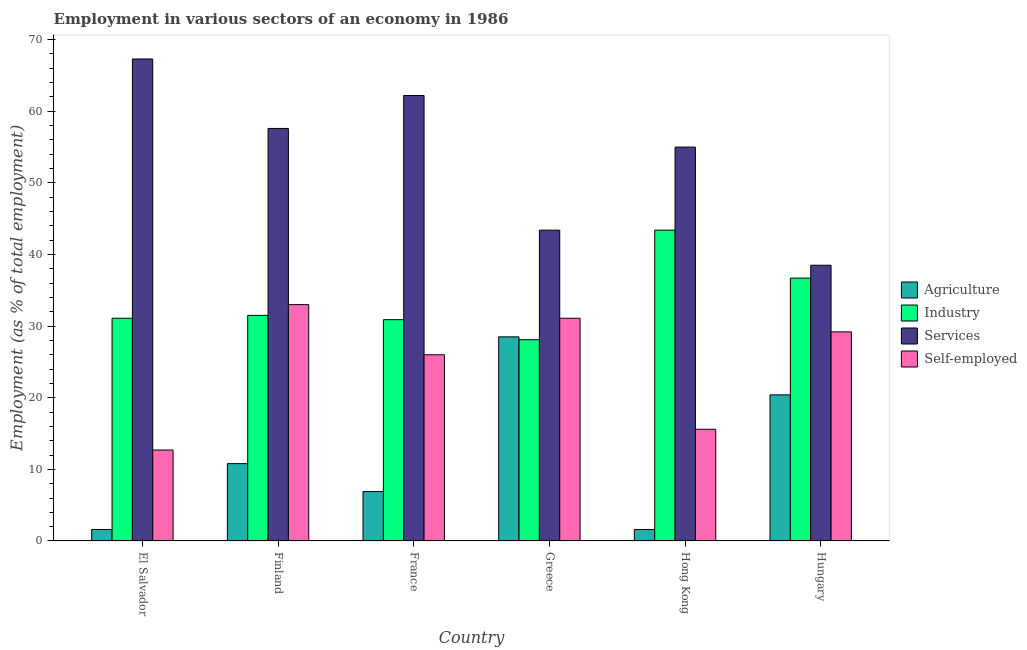How many different coloured bars are there?
Provide a succinct answer. 4. Are the number of bars per tick equal to the number of legend labels?
Keep it short and to the point. Yes. Are the number of bars on each tick of the X-axis equal?
Ensure brevity in your answer.  Yes. What is the label of the 5th group of bars from the left?
Provide a succinct answer. Hong Kong. In how many cases, is the number of bars for a given country not equal to the number of legend labels?
Ensure brevity in your answer.  0. What is the percentage of self employed workers in Hungary?
Your answer should be very brief. 29.2. Across all countries, what is the minimum percentage of workers in industry?
Make the answer very short. 28.1. In which country was the percentage of workers in industry minimum?
Give a very brief answer. Greece. What is the total percentage of self employed workers in the graph?
Offer a very short reply. 147.6. What is the difference between the percentage of self employed workers in El Salvador and that in Finland?
Your answer should be compact. -20.3. What is the difference between the percentage of workers in services in El Salvador and the percentage of workers in agriculture in Hong Kong?
Your answer should be compact. 65.7. What is the average percentage of workers in industry per country?
Provide a short and direct response. 33.62. What is the difference between the percentage of self employed workers and percentage of workers in agriculture in France?
Offer a terse response. 19.1. In how many countries, is the percentage of self employed workers greater than 10 %?
Offer a very short reply. 6. What is the ratio of the percentage of self employed workers in Finland to that in Hong Kong?
Give a very brief answer. 2.12. Is the percentage of workers in services in El Salvador less than that in France?
Your answer should be compact. No. Is the difference between the percentage of workers in agriculture in Hong Kong and Hungary greater than the difference between the percentage of self employed workers in Hong Kong and Hungary?
Provide a succinct answer. No. What is the difference between the highest and the second highest percentage of workers in services?
Offer a terse response. 5.1. What is the difference between the highest and the lowest percentage of workers in services?
Your answer should be very brief. 28.8. Is the sum of the percentage of self employed workers in France and Greece greater than the maximum percentage of workers in industry across all countries?
Offer a terse response. Yes. Is it the case that in every country, the sum of the percentage of workers in services and percentage of workers in industry is greater than the sum of percentage of workers in agriculture and percentage of self employed workers?
Provide a short and direct response. Yes. What does the 3rd bar from the left in El Salvador represents?
Make the answer very short. Services. What does the 3rd bar from the right in Greece represents?
Give a very brief answer. Industry. Is it the case that in every country, the sum of the percentage of workers in agriculture and percentage of workers in industry is greater than the percentage of workers in services?
Ensure brevity in your answer.  No. How many countries are there in the graph?
Your answer should be compact. 6. What is the difference between two consecutive major ticks on the Y-axis?
Offer a terse response. 10. Does the graph contain any zero values?
Ensure brevity in your answer.  No. How many legend labels are there?
Your answer should be compact. 4. What is the title of the graph?
Provide a succinct answer. Employment in various sectors of an economy in 1986. Does "Taxes on income" appear as one of the legend labels in the graph?
Provide a short and direct response. No. What is the label or title of the X-axis?
Provide a short and direct response. Country. What is the label or title of the Y-axis?
Your answer should be compact. Employment (as % of total employment). What is the Employment (as % of total employment) in Agriculture in El Salvador?
Ensure brevity in your answer.  1.6. What is the Employment (as % of total employment) in Industry in El Salvador?
Ensure brevity in your answer.  31.1. What is the Employment (as % of total employment) in Services in El Salvador?
Offer a terse response. 67.3. What is the Employment (as % of total employment) in Self-employed in El Salvador?
Make the answer very short. 12.7. What is the Employment (as % of total employment) in Agriculture in Finland?
Provide a short and direct response. 10.8. What is the Employment (as % of total employment) of Industry in Finland?
Ensure brevity in your answer.  31.5. What is the Employment (as % of total employment) of Services in Finland?
Offer a terse response. 57.6. What is the Employment (as % of total employment) of Agriculture in France?
Offer a terse response. 6.9. What is the Employment (as % of total employment) of Industry in France?
Make the answer very short. 30.9. What is the Employment (as % of total employment) of Services in France?
Offer a very short reply. 62.2. What is the Employment (as % of total employment) in Self-employed in France?
Give a very brief answer. 26. What is the Employment (as % of total employment) in Industry in Greece?
Your answer should be compact. 28.1. What is the Employment (as % of total employment) in Services in Greece?
Ensure brevity in your answer.  43.4. What is the Employment (as % of total employment) of Self-employed in Greece?
Give a very brief answer. 31.1. What is the Employment (as % of total employment) of Agriculture in Hong Kong?
Keep it short and to the point. 1.6. What is the Employment (as % of total employment) in Industry in Hong Kong?
Offer a terse response. 43.4. What is the Employment (as % of total employment) of Self-employed in Hong Kong?
Make the answer very short. 15.6. What is the Employment (as % of total employment) in Agriculture in Hungary?
Ensure brevity in your answer.  20.4. What is the Employment (as % of total employment) of Industry in Hungary?
Offer a terse response. 36.7. What is the Employment (as % of total employment) in Services in Hungary?
Keep it short and to the point. 38.5. What is the Employment (as % of total employment) in Self-employed in Hungary?
Offer a terse response. 29.2. Across all countries, what is the maximum Employment (as % of total employment) of Agriculture?
Provide a succinct answer. 28.5. Across all countries, what is the maximum Employment (as % of total employment) of Industry?
Provide a short and direct response. 43.4. Across all countries, what is the maximum Employment (as % of total employment) in Services?
Your response must be concise. 67.3. Across all countries, what is the minimum Employment (as % of total employment) of Agriculture?
Offer a very short reply. 1.6. Across all countries, what is the minimum Employment (as % of total employment) in Industry?
Keep it short and to the point. 28.1. Across all countries, what is the minimum Employment (as % of total employment) in Services?
Keep it short and to the point. 38.5. Across all countries, what is the minimum Employment (as % of total employment) of Self-employed?
Make the answer very short. 12.7. What is the total Employment (as % of total employment) in Agriculture in the graph?
Offer a very short reply. 69.8. What is the total Employment (as % of total employment) of Industry in the graph?
Make the answer very short. 201.7. What is the total Employment (as % of total employment) of Services in the graph?
Offer a very short reply. 324. What is the total Employment (as % of total employment) of Self-employed in the graph?
Your response must be concise. 147.6. What is the difference between the Employment (as % of total employment) of Agriculture in El Salvador and that in Finland?
Make the answer very short. -9.2. What is the difference between the Employment (as % of total employment) in Self-employed in El Salvador and that in Finland?
Offer a very short reply. -20.3. What is the difference between the Employment (as % of total employment) of Agriculture in El Salvador and that in France?
Offer a very short reply. -5.3. What is the difference between the Employment (as % of total employment) in Self-employed in El Salvador and that in France?
Make the answer very short. -13.3. What is the difference between the Employment (as % of total employment) in Agriculture in El Salvador and that in Greece?
Your answer should be compact. -26.9. What is the difference between the Employment (as % of total employment) in Services in El Salvador and that in Greece?
Provide a short and direct response. 23.9. What is the difference between the Employment (as % of total employment) in Self-employed in El Salvador and that in Greece?
Offer a very short reply. -18.4. What is the difference between the Employment (as % of total employment) in Agriculture in El Salvador and that in Hong Kong?
Your response must be concise. 0. What is the difference between the Employment (as % of total employment) in Industry in El Salvador and that in Hong Kong?
Provide a short and direct response. -12.3. What is the difference between the Employment (as % of total employment) of Agriculture in El Salvador and that in Hungary?
Your response must be concise. -18.8. What is the difference between the Employment (as % of total employment) of Industry in El Salvador and that in Hungary?
Your answer should be compact. -5.6. What is the difference between the Employment (as % of total employment) of Services in El Salvador and that in Hungary?
Your answer should be compact. 28.8. What is the difference between the Employment (as % of total employment) in Self-employed in El Salvador and that in Hungary?
Your answer should be compact. -16.5. What is the difference between the Employment (as % of total employment) of Industry in Finland and that in France?
Give a very brief answer. 0.6. What is the difference between the Employment (as % of total employment) of Self-employed in Finland and that in France?
Offer a terse response. 7. What is the difference between the Employment (as % of total employment) in Agriculture in Finland and that in Greece?
Give a very brief answer. -17.7. What is the difference between the Employment (as % of total employment) in Industry in Finland and that in Greece?
Ensure brevity in your answer.  3.4. What is the difference between the Employment (as % of total employment) of Services in Finland and that in Greece?
Offer a very short reply. 14.2. What is the difference between the Employment (as % of total employment) in Self-employed in Finland and that in Greece?
Provide a short and direct response. 1.9. What is the difference between the Employment (as % of total employment) of Agriculture in Finland and that in Hong Kong?
Make the answer very short. 9.2. What is the difference between the Employment (as % of total employment) of Services in Finland and that in Hong Kong?
Your response must be concise. 2.6. What is the difference between the Employment (as % of total employment) in Agriculture in Finland and that in Hungary?
Offer a very short reply. -9.6. What is the difference between the Employment (as % of total employment) of Services in Finland and that in Hungary?
Your response must be concise. 19.1. What is the difference between the Employment (as % of total employment) in Self-employed in Finland and that in Hungary?
Keep it short and to the point. 3.8. What is the difference between the Employment (as % of total employment) of Agriculture in France and that in Greece?
Keep it short and to the point. -21.6. What is the difference between the Employment (as % of total employment) of Self-employed in France and that in Greece?
Offer a terse response. -5.1. What is the difference between the Employment (as % of total employment) of Agriculture in France and that in Hong Kong?
Provide a succinct answer. 5.3. What is the difference between the Employment (as % of total employment) in Industry in France and that in Hong Kong?
Provide a succinct answer. -12.5. What is the difference between the Employment (as % of total employment) in Services in France and that in Hong Kong?
Offer a very short reply. 7.2. What is the difference between the Employment (as % of total employment) of Self-employed in France and that in Hong Kong?
Provide a succinct answer. 10.4. What is the difference between the Employment (as % of total employment) in Agriculture in France and that in Hungary?
Ensure brevity in your answer.  -13.5. What is the difference between the Employment (as % of total employment) of Services in France and that in Hungary?
Your answer should be very brief. 23.7. What is the difference between the Employment (as % of total employment) of Self-employed in France and that in Hungary?
Provide a succinct answer. -3.2. What is the difference between the Employment (as % of total employment) in Agriculture in Greece and that in Hong Kong?
Provide a succinct answer. 26.9. What is the difference between the Employment (as % of total employment) of Industry in Greece and that in Hong Kong?
Offer a terse response. -15.3. What is the difference between the Employment (as % of total employment) in Services in Greece and that in Hungary?
Provide a short and direct response. 4.9. What is the difference between the Employment (as % of total employment) in Self-employed in Greece and that in Hungary?
Make the answer very short. 1.9. What is the difference between the Employment (as % of total employment) in Agriculture in Hong Kong and that in Hungary?
Provide a short and direct response. -18.8. What is the difference between the Employment (as % of total employment) in Self-employed in Hong Kong and that in Hungary?
Provide a short and direct response. -13.6. What is the difference between the Employment (as % of total employment) in Agriculture in El Salvador and the Employment (as % of total employment) in Industry in Finland?
Your answer should be compact. -29.9. What is the difference between the Employment (as % of total employment) in Agriculture in El Salvador and the Employment (as % of total employment) in Services in Finland?
Your answer should be very brief. -56. What is the difference between the Employment (as % of total employment) of Agriculture in El Salvador and the Employment (as % of total employment) of Self-employed in Finland?
Offer a very short reply. -31.4. What is the difference between the Employment (as % of total employment) of Industry in El Salvador and the Employment (as % of total employment) of Services in Finland?
Keep it short and to the point. -26.5. What is the difference between the Employment (as % of total employment) in Services in El Salvador and the Employment (as % of total employment) in Self-employed in Finland?
Your answer should be compact. 34.3. What is the difference between the Employment (as % of total employment) of Agriculture in El Salvador and the Employment (as % of total employment) of Industry in France?
Provide a succinct answer. -29.3. What is the difference between the Employment (as % of total employment) of Agriculture in El Salvador and the Employment (as % of total employment) of Services in France?
Ensure brevity in your answer.  -60.6. What is the difference between the Employment (as % of total employment) of Agriculture in El Salvador and the Employment (as % of total employment) of Self-employed in France?
Your answer should be very brief. -24.4. What is the difference between the Employment (as % of total employment) of Industry in El Salvador and the Employment (as % of total employment) of Services in France?
Your answer should be compact. -31.1. What is the difference between the Employment (as % of total employment) of Services in El Salvador and the Employment (as % of total employment) of Self-employed in France?
Give a very brief answer. 41.3. What is the difference between the Employment (as % of total employment) in Agriculture in El Salvador and the Employment (as % of total employment) in Industry in Greece?
Provide a short and direct response. -26.5. What is the difference between the Employment (as % of total employment) in Agriculture in El Salvador and the Employment (as % of total employment) in Services in Greece?
Offer a terse response. -41.8. What is the difference between the Employment (as % of total employment) in Agriculture in El Salvador and the Employment (as % of total employment) in Self-employed in Greece?
Make the answer very short. -29.5. What is the difference between the Employment (as % of total employment) of Industry in El Salvador and the Employment (as % of total employment) of Services in Greece?
Ensure brevity in your answer.  -12.3. What is the difference between the Employment (as % of total employment) of Services in El Salvador and the Employment (as % of total employment) of Self-employed in Greece?
Provide a succinct answer. 36.2. What is the difference between the Employment (as % of total employment) of Agriculture in El Salvador and the Employment (as % of total employment) of Industry in Hong Kong?
Give a very brief answer. -41.8. What is the difference between the Employment (as % of total employment) of Agriculture in El Salvador and the Employment (as % of total employment) of Services in Hong Kong?
Ensure brevity in your answer.  -53.4. What is the difference between the Employment (as % of total employment) of Agriculture in El Salvador and the Employment (as % of total employment) of Self-employed in Hong Kong?
Provide a short and direct response. -14. What is the difference between the Employment (as % of total employment) of Industry in El Salvador and the Employment (as % of total employment) of Services in Hong Kong?
Your answer should be compact. -23.9. What is the difference between the Employment (as % of total employment) of Industry in El Salvador and the Employment (as % of total employment) of Self-employed in Hong Kong?
Give a very brief answer. 15.5. What is the difference between the Employment (as % of total employment) of Services in El Salvador and the Employment (as % of total employment) of Self-employed in Hong Kong?
Give a very brief answer. 51.7. What is the difference between the Employment (as % of total employment) in Agriculture in El Salvador and the Employment (as % of total employment) in Industry in Hungary?
Make the answer very short. -35.1. What is the difference between the Employment (as % of total employment) of Agriculture in El Salvador and the Employment (as % of total employment) of Services in Hungary?
Ensure brevity in your answer.  -36.9. What is the difference between the Employment (as % of total employment) of Agriculture in El Salvador and the Employment (as % of total employment) of Self-employed in Hungary?
Provide a short and direct response. -27.6. What is the difference between the Employment (as % of total employment) in Industry in El Salvador and the Employment (as % of total employment) in Services in Hungary?
Offer a very short reply. -7.4. What is the difference between the Employment (as % of total employment) in Services in El Salvador and the Employment (as % of total employment) in Self-employed in Hungary?
Ensure brevity in your answer.  38.1. What is the difference between the Employment (as % of total employment) of Agriculture in Finland and the Employment (as % of total employment) of Industry in France?
Give a very brief answer. -20.1. What is the difference between the Employment (as % of total employment) in Agriculture in Finland and the Employment (as % of total employment) in Services in France?
Keep it short and to the point. -51.4. What is the difference between the Employment (as % of total employment) in Agriculture in Finland and the Employment (as % of total employment) in Self-employed in France?
Ensure brevity in your answer.  -15.2. What is the difference between the Employment (as % of total employment) in Industry in Finland and the Employment (as % of total employment) in Services in France?
Your answer should be very brief. -30.7. What is the difference between the Employment (as % of total employment) of Services in Finland and the Employment (as % of total employment) of Self-employed in France?
Your response must be concise. 31.6. What is the difference between the Employment (as % of total employment) in Agriculture in Finland and the Employment (as % of total employment) in Industry in Greece?
Your answer should be compact. -17.3. What is the difference between the Employment (as % of total employment) in Agriculture in Finland and the Employment (as % of total employment) in Services in Greece?
Your response must be concise. -32.6. What is the difference between the Employment (as % of total employment) of Agriculture in Finland and the Employment (as % of total employment) of Self-employed in Greece?
Provide a short and direct response. -20.3. What is the difference between the Employment (as % of total employment) in Industry in Finland and the Employment (as % of total employment) in Services in Greece?
Offer a very short reply. -11.9. What is the difference between the Employment (as % of total employment) of Industry in Finland and the Employment (as % of total employment) of Self-employed in Greece?
Offer a terse response. 0.4. What is the difference between the Employment (as % of total employment) of Services in Finland and the Employment (as % of total employment) of Self-employed in Greece?
Make the answer very short. 26.5. What is the difference between the Employment (as % of total employment) of Agriculture in Finland and the Employment (as % of total employment) of Industry in Hong Kong?
Your answer should be very brief. -32.6. What is the difference between the Employment (as % of total employment) of Agriculture in Finland and the Employment (as % of total employment) of Services in Hong Kong?
Offer a terse response. -44.2. What is the difference between the Employment (as % of total employment) in Industry in Finland and the Employment (as % of total employment) in Services in Hong Kong?
Offer a very short reply. -23.5. What is the difference between the Employment (as % of total employment) of Agriculture in Finland and the Employment (as % of total employment) of Industry in Hungary?
Ensure brevity in your answer.  -25.9. What is the difference between the Employment (as % of total employment) of Agriculture in Finland and the Employment (as % of total employment) of Services in Hungary?
Give a very brief answer. -27.7. What is the difference between the Employment (as % of total employment) in Agriculture in Finland and the Employment (as % of total employment) in Self-employed in Hungary?
Offer a terse response. -18.4. What is the difference between the Employment (as % of total employment) in Services in Finland and the Employment (as % of total employment) in Self-employed in Hungary?
Your answer should be very brief. 28.4. What is the difference between the Employment (as % of total employment) of Agriculture in France and the Employment (as % of total employment) of Industry in Greece?
Offer a very short reply. -21.2. What is the difference between the Employment (as % of total employment) in Agriculture in France and the Employment (as % of total employment) in Services in Greece?
Your answer should be compact. -36.5. What is the difference between the Employment (as % of total employment) in Agriculture in France and the Employment (as % of total employment) in Self-employed in Greece?
Ensure brevity in your answer.  -24.2. What is the difference between the Employment (as % of total employment) in Industry in France and the Employment (as % of total employment) in Services in Greece?
Provide a succinct answer. -12.5. What is the difference between the Employment (as % of total employment) of Services in France and the Employment (as % of total employment) of Self-employed in Greece?
Ensure brevity in your answer.  31.1. What is the difference between the Employment (as % of total employment) of Agriculture in France and the Employment (as % of total employment) of Industry in Hong Kong?
Provide a short and direct response. -36.5. What is the difference between the Employment (as % of total employment) of Agriculture in France and the Employment (as % of total employment) of Services in Hong Kong?
Provide a short and direct response. -48.1. What is the difference between the Employment (as % of total employment) in Industry in France and the Employment (as % of total employment) in Services in Hong Kong?
Provide a short and direct response. -24.1. What is the difference between the Employment (as % of total employment) of Services in France and the Employment (as % of total employment) of Self-employed in Hong Kong?
Offer a terse response. 46.6. What is the difference between the Employment (as % of total employment) in Agriculture in France and the Employment (as % of total employment) in Industry in Hungary?
Provide a short and direct response. -29.8. What is the difference between the Employment (as % of total employment) of Agriculture in France and the Employment (as % of total employment) of Services in Hungary?
Your response must be concise. -31.6. What is the difference between the Employment (as % of total employment) of Agriculture in France and the Employment (as % of total employment) of Self-employed in Hungary?
Offer a terse response. -22.3. What is the difference between the Employment (as % of total employment) in Industry in France and the Employment (as % of total employment) in Self-employed in Hungary?
Keep it short and to the point. 1.7. What is the difference between the Employment (as % of total employment) of Agriculture in Greece and the Employment (as % of total employment) of Industry in Hong Kong?
Your response must be concise. -14.9. What is the difference between the Employment (as % of total employment) of Agriculture in Greece and the Employment (as % of total employment) of Services in Hong Kong?
Your response must be concise. -26.5. What is the difference between the Employment (as % of total employment) of Agriculture in Greece and the Employment (as % of total employment) of Self-employed in Hong Kong?
Offer a very short reply. 12.9. What is the difference between the Employment (as % of total employment) of Industry in Greece and the Employment (as % of total employment) of Services in Hong Kong?
Your response must be concise. -26.9. What is the difference between the Employment (as % of total employment) of Industry in Greece and the Employment (as % of total employment) of Self-employed in Hong Kong?
Your answer should be very brief. 12.5. What is the difference between the Employment (as % of total employment) in Services in Greece and the Employment (as % of total employment) in Self-employed in Hong Kong?
Your answer should be compact. 27.8. What is the difference between the Employment (as % of total employment) in Agriculture in Greece and the Employment (as % of total employment) in Industry in Hungary?
Offer a terse response. -8.2. What is the difference between the Employment (as % of total employment) in Industry in Greece and the Employment (as % of total employment) in Services in Hungary?
Provide a short and direct response. -10.4. What is the difference between the Employment (as % of total employment) of Industry in Greece and the Employment (as % of total employment) of Self-employed in Hungary?
Your answer should be very brief. -1.1. What is the difference between the Employment (as % of total employment) of Agriculture in Hong Kong and the Employment (as % of total employment) of Industry in Hungary?
Offer a terse response. -35.1. What is the difference between the Employment (as % of total employment) in Agriculture in Hong Kong and the Employment (as % of total employment) in Services in Hungary?
Ensure brevity in your answer.  -36.9. What is the difference between the Employment (as % of total employment) of Agriculture in Hong Kong and the Employment (as % of total employment) of Self-employed in Hungary?
Provide a succinct answer. -27.6. What is the difference between the Employment (as % of total employment) in Industry in Hong Kong and the Employment (as % of total employment) in Services in Hungary?
Provide a succinct answer. 4.9. What is the difference between the Employment (as % of total employment) in Services in Hong Kong and the Employment (as % of total employment) in Self-employed in Hungary?
Your answer should be compact. 25.8. What is the average Employment (as % of total employment) in Agriculture per country?
Provide a succinct answer. 11.63. What is the average Employment (as % of total employment) of Industry per country?
Provide a succinct answer. 33.62. What is the average Employment (as % of total employment) in Self-employed per country?
Your answer should be compact. 24.6. What is the difference between the Employment (as % of total employment) in Agriculture and Employment (as % of total employment) in Industry in El Salvador?
Keep it short and to the point. -29.5. What is the difference between the Employment (as % of total employment) in Agriculture and Employment (as % of total employment) in Services in El Salvador?
Keep it short and to the point. -65.7. What is the difference between the Employment (as % of total employment) of Industry and Employment (as % of total employment) of Services in El Salvador?
Keep it short and to the point. -36.2. What is the difference between the Employment (as % of total employment) of Services and Employment (as % of total employment) of Self-employed in El Salvador?
Provide a short and direct response. 54.6. What is the difference between the Employment (as % of total employment) in Agriculture and Employment (as % of total employment) in Industry in Finland?
Provide a short and direct response. -20.7. What is the difference between the Employment (as % of total employment) in Agriculture and Employment (as % of total employment) in Services in Finland?
Offer a terse response. -46.8. What is the difference between the Employment (as % of total employment) in Agriculture and Employment (as % of total employment) in Self-employed in Finland?
Provide a short and direct response. -22.2. What is the difference between the Employment (as % of total employment) in Industry and Employment (as % of total employment) in Services in Finland?
Your response must be concise. -26.1. What is the difference between the Employment (as % of total employment) of Services and Employment (as % of total employment) of Self-employed in Finland?
Provide a short and direct response. 24.6. What is the difference between the Employment (as % of total employment) of Agriculture and Employment (as % of total employment) of Industry in France?
Offer a terse response. -24. What is the difference between the Employment (as % of total employment) of Agriculture and Employment (as % of total employment) of Services in France?
Offer a very short reply. -55.3. What is the difference between the Employment (as % of total employment) in Agriculture and Employment (as % of total employment) in Self-employed in France?
Your answer should be very brief. -19.1. What is the difference between the Employment (as % of total employment) in Industry and Employment (as % of total employment) in Services in France?
Make the answer very short. -31.3. What is the difference between the Employment (as % of total employment) of Industry and Employment (as % of total employment) of Self-employed in France?
Keep it short and to the point. 4.9. What is the difference between the Employment (as % of total employment) in Services and Employment (as % of total employment) in Self-employed in France?
Provide a succinct answer. 36.2. What is the difference between the Employment (as % of total employment) in Agriculture and Employment (as % of total employment) in Services in Greece?
Offer a very short reply. -14.9. What is the difference between the Employment (as % of total employment) in Agriculture and Employment (as % of total employment) in Self-employed in Greece?
Give a very brief answer. -2.6. What is the difference between the Employment (as % of total employment) in Industry and Employment (as % of total employment) in Services in Greece?
Give a very brief answer. -15.3. What is the difference between the Employment (as % of total employment) of Services and Employment (as % of total employment) of Self-employed in Greece?
Keep it short and to the point. 12.3. What is the difference between the Employment (as % of total employment) in Agriculture and Employment (as % of total employment) in Industry in Hong Kong?
Keep it short and to the point. -41.8. What is the difference between the Employment (as % of total employment) in Agriculture and Employment (as % of total employment) in Services in Hong Kong?
Provide a short and direct response. -53.4. What is the difference between the Employment (as % of total employment) in Agriculture and Employment (as % of total employment) in Self-employed in Hong Kong?
Provide a short and direct response. -14. What is the difference between the Employment (as % of total employment) of Industry and Employment (as % of total employment) of Self-employed in Hong Kong?
Keep it short and to the point. 27.8. What is the difference between the Employment (as % of total employment) in Services and Employment (as % of total employment) in Self-employed in Hong Kong?
Your answer should be very brief. 39.4. What is the difference between the Employment (as % of total employment) of Agriculture and Employment (as % of total employment) of Industry in Hungary?
Give a very brief answer. -16.3. What is the difference between the Employment (as % of total employment) in Agriculture and Employment (as % of total employment) in Services in Hungary?
Offer a very short reply. -18.1. What is the difference between the Employment (as % of total employment) in Agriculture and Employment (as % of total employment) in Self-employed in Hungary?
Keep it short and to the point. -8.8. What is the difference between the Employment (as % of total employment) in Industry and Employment (as % of total employment) in Services in Hungary?
Ensure brevity in your answer.  -1.8. What is the difference between the Employment (as % of total employment) in Industry and Employment (as % of total employment) in Self-employed in Hungary?
Provide a succinct answer. 7.5. What is the difference between the Employment (as % of total employment) in Services and Employment (as % of total employment) in Self-employed in Hungary?
Provide a short and direct response. 9.3. What is the ratio of the Employment (as % of total employment) of Agriculture in El Salvador to that in Finland?
Provide a short and direct response. 0.15. What is the ratio of the Employment (as % of total employment) in Industry in El Salvador to that in Finland?
Ensure brevity in your answer.  0.99. What is the ratio of the Employment (as % of total employment) of Services in El Salvador to that in Finland?
Give a very brief answer. 1.17. What is the ratio of the Employment (as % of total employment) of Self-employed in El Salvador to that in Finland?
Keep it short and to the point. 0.38. What is the ratio of the Employment (as % of total employment) in Agriculture in El Salvador to that in France?
Your answer should be compact. 0.23. What is the ratio of the Employment (as % of total employment) of Industry in El Salvador to that in France?
Keep it short and to the point. 1.01. What is the ratio of the Employment (as % of total employment) in Services in El Salvador to that in France?
Your response must be concise. 1.08. What is the ratio of the Employment (as % of total employment) in Self-employed in El Salvador to that in France?
Ensure brevity in your answer.  0.49. What is the ratio of the Employment (as % of total employment) in Agriculture in El Salvador to that in Greece?
Keep it short and to the point. 0.06. What is the ratio of the Employment (as % of total employment) of Industry in El Salvador to that in Greece?
Your answer should be compact. 1.11. What is the ratio of the Employment (as % of total employment) in Services in El Salvador to that in Greece?
Give a very brief answer. 1.55. What is the ratio of the Employment (as % of total employment) of Self-employed in El Salvador to that in Greece?
Your answer should be compact. 0.41. What is the ratio of the Employment (as % of total employment) in Industry in El Salvador to that in Hong Kong?
Your answer should be very brief. 0.72. What is the ratio of the Employment (as % of total employment) of Services in El Salvador to that in Hong Kong?
Offer a very short reply. 1.22. What is the ratio of the Employment (as % of total employment) of Self-employed in El Salvador to that in Hong Kong?
Ensure brevity in your answer.  0.81. What is the ratio of the Employment (as % of total employment) of Agriculture in El Salvador to that in Hungary?
Keep it short and to the point. 0.08. What is the ratio of the Employment (as % of total employment) in Industry in El Salvador to that in Hungary?
Your answer should be very brief. 0.85. What is the ratio of the Employment (as % of total employment) in Services in El Salvador to that in Hungary?
Provide a succinct answer. 1.75. What is the ratio of the Employment (as % of total employment) in Self-employed in El Salvador to that in Hungary?
Keep it short and to the point. 0.43. What is the ratio of the Employment (as % of total employment) in Agriculture in Finland to that in France?
Your answer should be compact. 1.57. What is the ratio of the Employment (as % of total employment) in Industry in Finland to that in France?
Give a very brief answer. 1.02. What is the ratio of the Employment (as % of total employment) in Services in Finland to that in France?
Keep it short and to the point. 0.93. What is the ratio of the Employment (as % of total employment) of Self-employed in Finland to that in France?
Keep it short and to the point. 1.27. What is the ratio of the Employment (as % of total employment) in Agriculture in Finland to that in Greece?
Provide a succinct answer. 0.38. What is the ratio of the Employment (as % of total employment) in Industry in Finland to that in Greece?
Offer a terse response. 1.12. What is the ratio of the Employment (as % of total employment) of Services in Finland to that in Greece?
Ensure brevity in your answer.  1.33. What is the ratio of the Employment (as % of total employment) in Self-employed in Finland to that in Greece?
Your answer should be compact. 1.06. What is the ratio of the Employment (as % of total employment) of Agriculture in Finland to that in Hong Kong?
Your answer should be compact. 6.75. What is the ratio of the Employment (as % of total employment) of Industry in Finland to that in Hong Kong?
Your answer should be very brief. 0.73. What is the ratio of the Employment (as % of total employment) in Services in Finland to that in Hong Kong?
Your response must be concise. 1.05. What is the ratio of the Employment (as % of total employment) of Self-employed in Finland to that in Hong Kong?
Your answer should be very brief. 2.12. What is the ratio of the Employment (as % of total employment) in Agriculture in Finland to that in Hungary?
Your answer should be very brief. 0.53. What is the ratio of the Employment (as % of total employment) of Industry in Finland to that in Hungary?
Offer a very short reply. 0.86. What is the ratio of the Employment (as % of total employment) in Services in Finland to that in Hungary?
Your response must be concise. 1.5. What is the ratio of the Employment (as % of total employment) of Self-employed in Finland to that in Hungary?
Your answer should be compact. 1.13. What is the ratio of the Employment (as % of total employment) in Agriculture in France to that in Greece?
Provide a succinct answer. 0.24. What is the ratio of the Employment (as % of total employment) in Industry in France to that in Greece?
Your answer should be compact. 1.1. What is the ratio of the Employment (as % of total employment) of Services in France to that in Greece?
Give a very brief answer. 1.43. What is the ratio of the Employment (as % of total employment) of Self-employed in France to that in Greece?
Offer a terse response. 0.84. What is the ratio of the Employment (as % of total employment) in Agriculture in France to that in Hong Kong?
Your response must be concise. 4.31. What is the ratio of the Employment (as % of total employment) of Industry in France to that in Hong Kong?
Offer a very short reply. 0.71. What is the ratio of the Employment (as % of total employment) of Services in France to that in Hong Kong?
Keep it short and to the point. 1.13. What is the ratio of the Employment (as % of total employment) of Self-employed in France to that in Hong Kong?
Provide a short and direct response. 1.67. What is the ratio of the Employment (as % of total employment) in Agriculture in France to that in Hungary?
Your response must be concise. 0.34. What is the ratio of the Employment (as % of total employment) in Industry in France to that in Hungary?
Your response must be concise. 0.84. What is the ratio of the Employment (as % of total employment) in Services in France to that in Hungary?
Offer a very short reply. 1.62. What is the ratio of the Employment (as % of total employment) of Self-employed in France to that in Hungary?
Offer a terse response. 0.89. What is the ratio of the Employment (as % of total employment) of Agriculture in Greece to that in Hong Kong?
Your answer should be compact. 17.81. What is the ratio of the Employment (as % of total employment) in Industry in Greece to that in Hong Kong?
Keep it short and to the point. 0.65. What is the ratio of the Employment (as % of total employment) of Services in Greece to that in Hong Kong?
Provide a succinct answer. 0.79. What is the ratio of the Employment (as % of total employment) in Self-employed in Greece to that in Hong Kong?
Keep it short and to the point. 1.99. What is the ratio of the Employment (as % of total employment) in Agriculture in Greece to that in Hungary?
Provide a succinct answer. 1.4. What is the ratio of the Employment (as % of total employment) in Industry in Greece to that in Hungary?
Your answer should be very brief. 0.77. What is the ratio of the Employment (as % of total employment) of Services in Greece to that in Hungary?
Give a very brief answer. 1.13. What is the ratio of the Employment (as % of total employment) of Self-employed in Greece to that in Hungary?
Make the answer very short. 1.07. What is the ratio of the Employment (as % of total employment) of Agriculture in Hong Kong to that in Hungary?
Keep it short and to the point. 0.08. What is the ratio of the Employment (as % of total employment) of Industry in Hong Kong to that in Hungary?
Keep it short and to the point. 1.18. What is the ratio of the Employment (as % of total employment) of Services in Hong Kong to that in Hungary?
Provide a succinct answer. 1.43. What is the ratio of the Employment (as % of total employment) of Self-employed in Hong Kong to that in Hungary?
Your answer should be compact. 0.53. What is the difference between the highest and the second highest Employment (as % of total employment) in Agriculture?
Provide a short and direct response. 8.1. What is the difference between the highest and the lowest Employment (as % of total employment) of Agriculture?
Your answer should be very brief. 26.9. What is the difference between the highest and the lowest Employment (as % of total employment) in Services?
Offer a very short reply. 28.8. What is the difference between the highest and the lowest Employment (as % of total employment) of Self-employed?
Your answer should be compact. 20.3. 